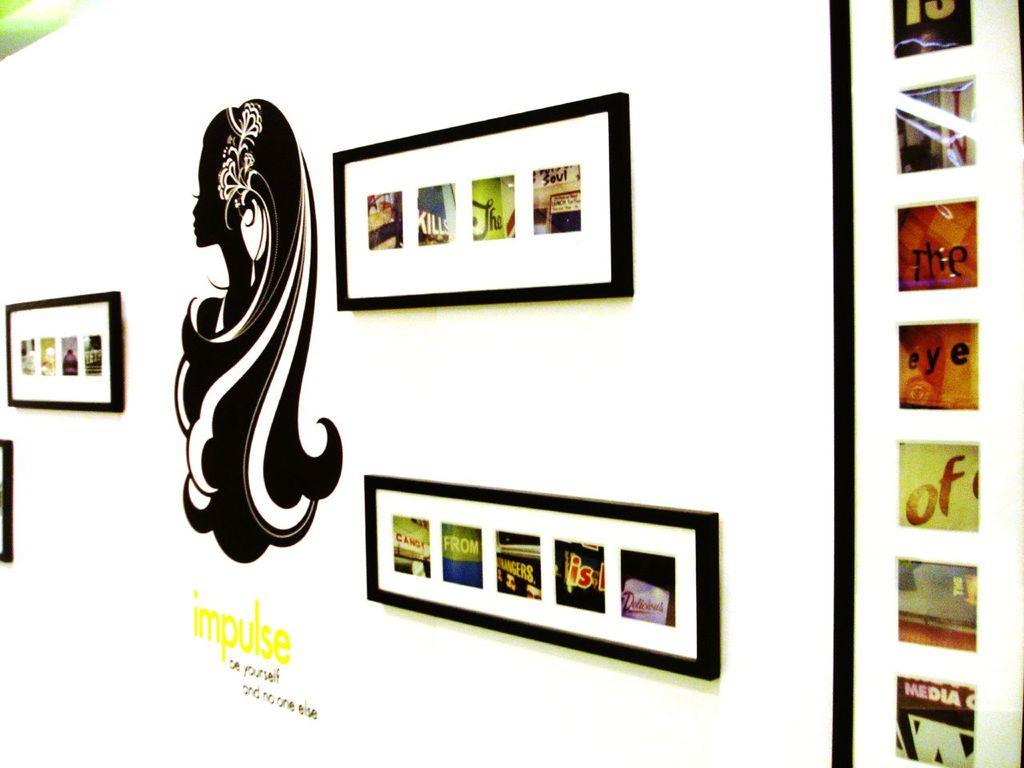What does the image say that is positioned third from the top on the right side?
Give a very brief answer. The. What body parts is mentioned on the images on the right side in the center?
Provide a short and direct response. Eye. 